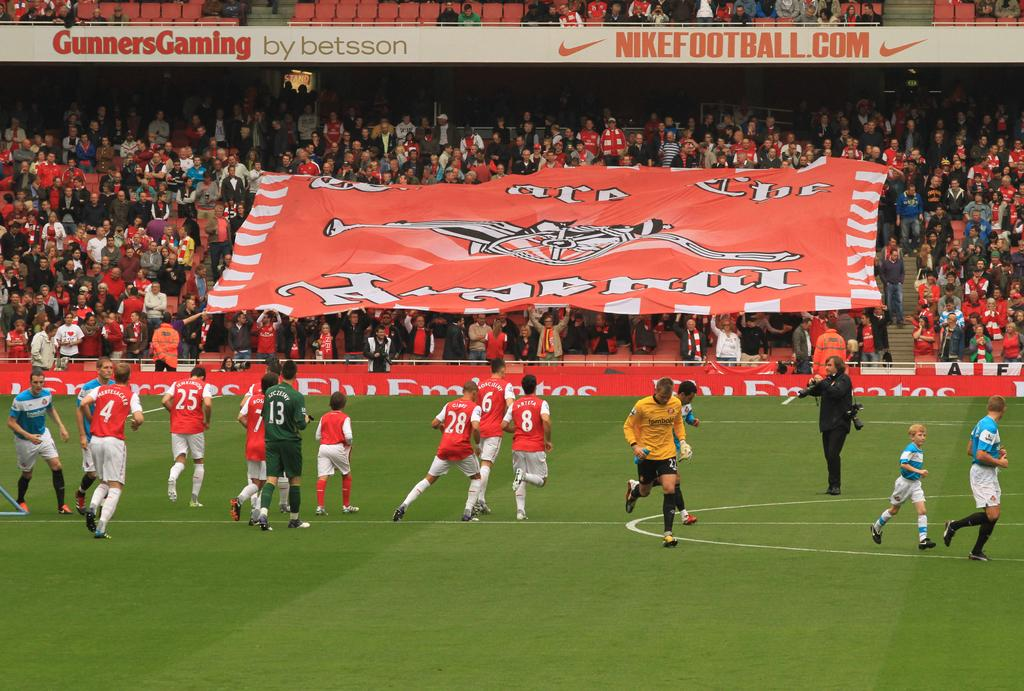What is the man in the image holding? The man is holding a camera in the image. What are some people in the image doing? Some people are on the ground in the image. What can be seen in the background of the image? There is a group of people, a banner, and some objects in the background of the image. What type of pest can be seen crawling on the banner in the image? There is no pest visible on the banner in the image. What type of grain is being harvested by the people on the ground in the image? There is no grain harvesting depicted in the image; people are simply on the ground. 